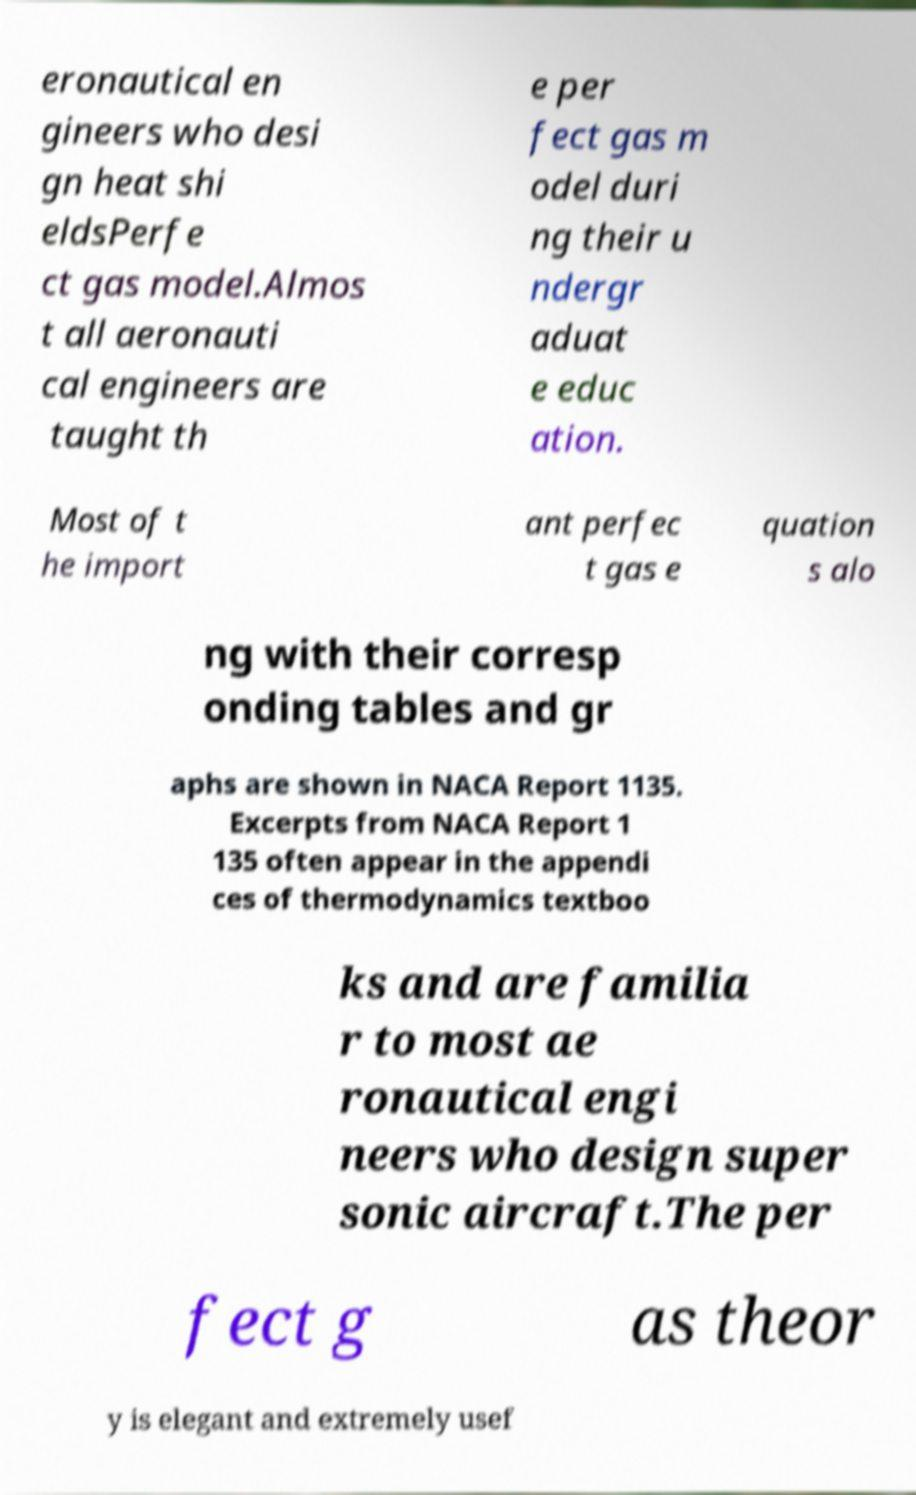Can you accurately transcribe the text from the provided image for me? eronautical en gineers who desi gn heat shi eldsPerfe ct gas model.Almos t all aeronauti cal engineers are taught th e per fect gas m odel duri ng their u ndergr aduat e educ ation. Most of t he import ant perfec t gas e quation s alo ng with their corresp onding tables and gr aphs are shown in NACA Report 1135. Excerpts from NACA Report 1 135 often appear in the appendi ces of thermodynamics textboo ks and are familia r to most ae ronautical engi neers who design super sonic aircraft.The per fect g as theor y is elegant and extremely usef 